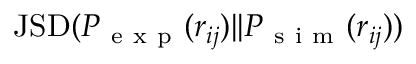<formula> <loc_0><loc_0><loc_500><loc_500>J S D ( P _ { e x p } ( r _ { i j } ) | | P _ { s i m } ( r _ { i j } ) )</formula> 